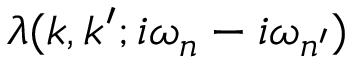Convert formula to latex. <formula><loc_0><loc_0><loc_500><loc_500>\lambda ( k , k ^ { \prime } ; i \omega _ { n } - i \omega _ { n ^ { \prime } } )</formula> 